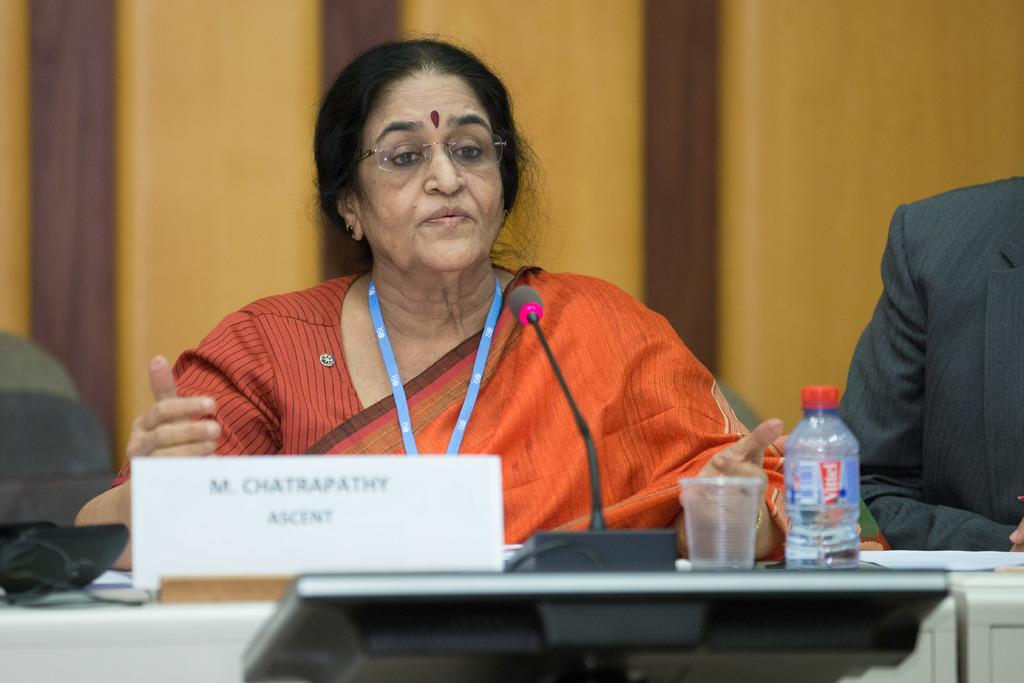Who is the main subject in the image? There is a woman in the image. What is the woman doing in the image? The woman is talking on a microphone. Can you describe the woman's appearance? The woman is wearing spectacles. What objects are on the table in the image? There is a bottle and a glass on the table. What type of umbrella is being used to shield the woman from the sun in the image? There is no umbrella present in the image, and the sun is not visible either. 